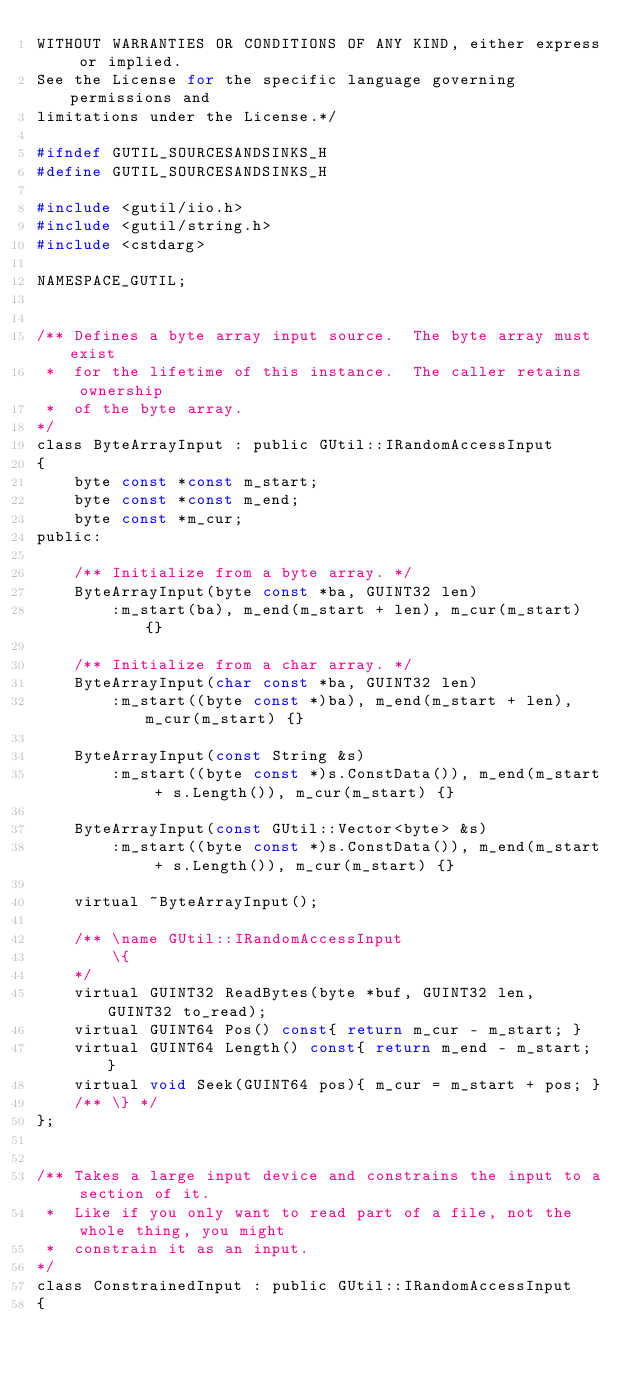Convert code to text. <code><loc_0><loc_0><loc_500><loc_500><_C_>WITHOUT WARRANTIES OR CONDITIONS OF ANY KIND, either express or implied.
See the License for the specific language governing permissions and
limitations under the License.*/

#ifndef GUTIL_SOURCESANDSINKS_H
#define GUTIL_SOURCESANDSINKS_H

#include <gutil/iio.h>
#include <gutil/string.h>
#include <cstdarg>

NAMESPACE_GUTIL;


/** Defines a byte array input source.  The byte array must exist
 *  for the lifetime of this instance.  The caller retains ownership
 *  of the byte array.
*/
class ByteArrayInput : public GUtil::IRandomAccessInput
{
    byte const *const m_start;
    byte const *const m_end;
    byte const *m_cur;
public:

    /** Initialize from a byte array. */
    ByteArrayInput(byte const *ba, GUINT32 len)
        :m_start(ba), m_end(m_start + len), m_cur(m_start) {}

    /** Initialize from a char array. */
    ByteArrayInput(char const *ba, GUINT32 len)
        :m_start((byte const *)ba), m_end(m_start + len), m_cur(m_start) {}

    ByteArrayInput(const String &s)
        :m_start((byte const *)s.ConstData()), m_end(m_start + s.Length()), m_cur(m_start) {}

    ByteArrayInput(const GUtil::Vector<byte> &s)
        :m_start((byte const *)s.ConstData()), m_end(m_start + s.Length()), m_cur(m_start) {}

    virtual ~ByteArrayInput();

    /** \name GUtil::IRandomAccessInput
        \{
    */
    virtual GUINT32 ReadBytes(byte *buf, GUINT32 len, GUINT32 to_read);
    virtual GUINT64 Pos() const{ return m_cur - m_start; }
    virtual GUINT64 Length() const{ return m_end - m_start; }
    virtual void Seek(GUINT64 pos){ m_cur = m_start + pos; }
    /** \} */
};


/** Takes a large input device and constrains the input to a section of it.
 *  Like if you only want to read part of a file, not the whole thing, you might
 *  constrain it as an input.
*/
class ConstrainedInput : public GUtil::IRandomAccessInput
{</code> 